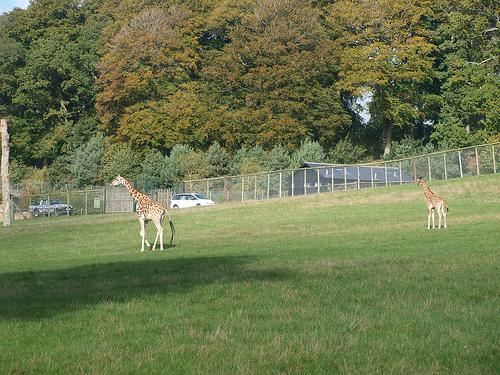Describe the image whilst focusing on the presence of vehicles and buildings. A white car and a gray truck are parked near a black building, with two giraffes standing in the foreground field. Highlight the main aspects of the surrounding environment in the image. The image features a grassy field with mostly green grass, some yellow spots, and leafy trees on a hill. Briefly describe the overall scene of the image and the main elements present. The image features two giraffes in a grassy field with vehicles and a building, and a mix of green and yellow vegetation. Provide a concise description of the main animals in the image and their appearance. Two giraffes, one larger and one smaller, are standing in a field with brown and white markings. Explain the different types of fences seen in the image and their locations. A wood fence gate is visible on the fence, with a chain link fence in the background behind two giraffes in the field. Describe the objects in front and behind the main subject. In front of the two giraffes, there is a white car, and behind them, there is a gray truck, a building, and a fence. Mention the main subject and what they are doing along with the secondary objects present. Two giraffes, one larger than the other, are in a field with a car and truck nearby and a building in the background. Describe the grass and its colors in various parts of the image. The grass in the image is primarily green, with some areas of short, dark green grass and patches of greenish-yellow grass. Mention the main subject and their position relative to the other objects in the image. Two giraffes, one on the right smaller and one on the left larger, are situated in a field with vehicles and a building nearby. Use rich descriptive language to paint a picture of the primary focus of the image. A pair of majestic giraffes, adorned with intricate brown and white patterns, gracefully stand in a verdant field sprinkled with yellow hues. 